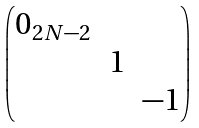<formula> <loc_0><loc_0><loc_500><loc_500>\begin{pmatrix} 0 _ { 2 N - 2 } & & \\ & 1 & \\ & & - 1 \end{pmatrix}</formula> 